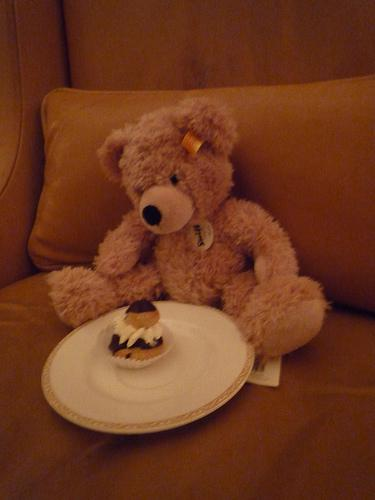Question: what kind of object is in the chair?
Choices:
A. Pillow.
B. Teddy bear.
C. Stuffed animal.
D. Hello Kitty.
Answer with the letter. Answer: C Question: what animal is the stuffed toy made to resemble?
Choices:
A. Dog.
B. Cat.
C. Elephant.
D. Bear.
Answer with the letter. Answer: D Question: what is in front of the bear?
Choices:
A. Silverware.
B. Napkin.
C. White plate.
D. Tea service.
Answer with the letter. Answer: C 